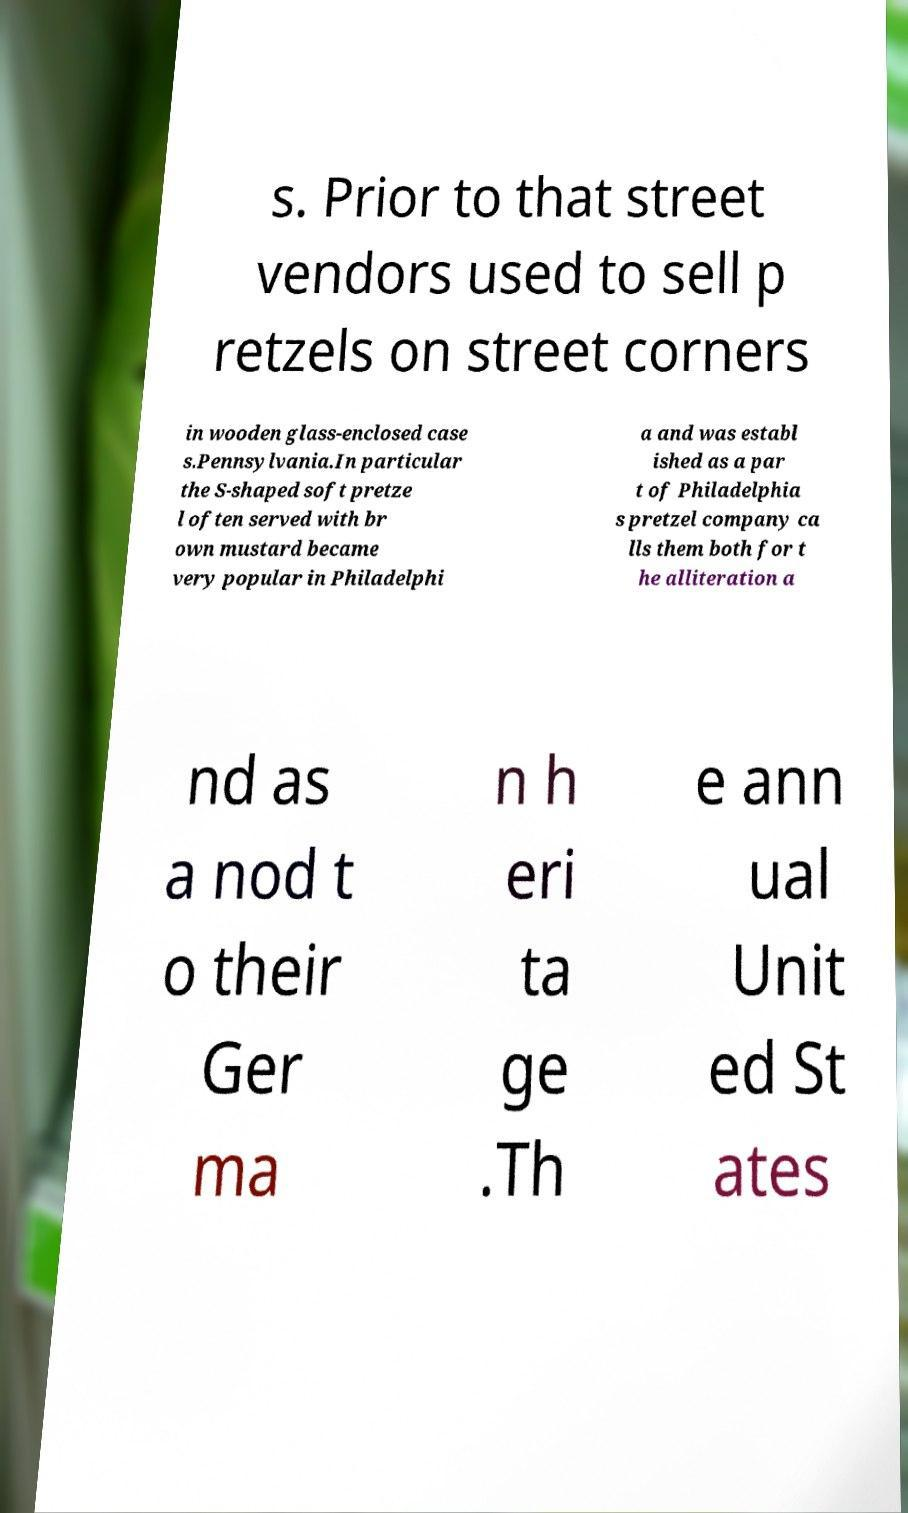Please read and relay the text visible in this image. What does it say? s. Prior to that street vendors used to sell p retzels on street corners in wooden glass-enclosed case s.Pennsylvania.In particular the S-shaped soft pretze l often served with br own mustard became very popular in Philadelphi a and was establ ished as a par t of Philadelphia s pretzel company ca lls them both for t he alliteration a nd as a nod t o their Ger ma n h eri ta ge .Th e ann ual Unit ed St ates 